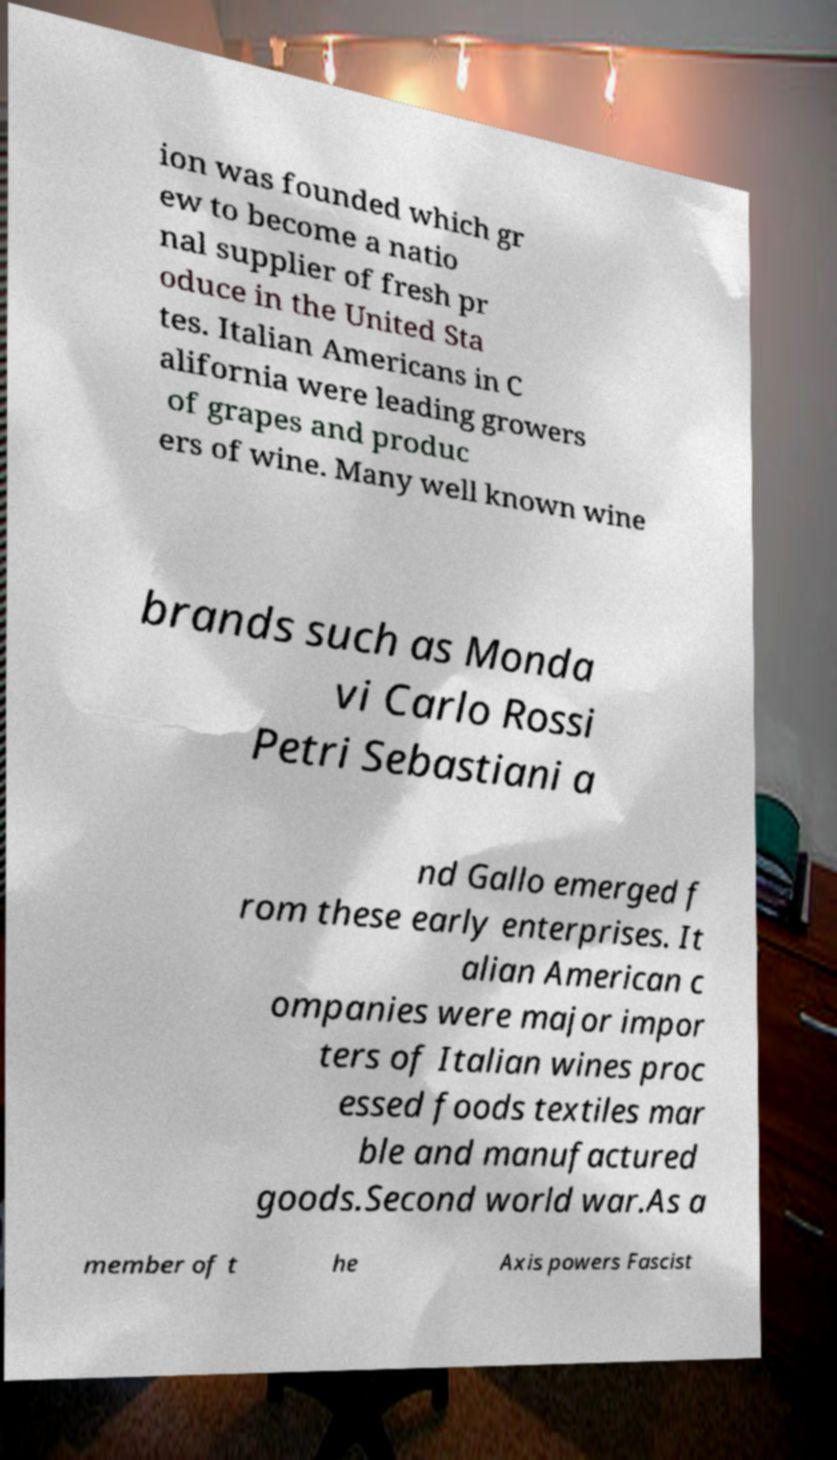Could you extract and type out the text from this image? ion was founded which gr ew to become a natio nal supplier of fresh pr oduce in the United Sta tes. Italian Americans in C alifornia were leading growers of grapes and produc ers of wine. Many well known wine brands such as Monda vi Carlo Rossi Petri Sebastiani a nd Gallo emerged f rom these early enterprises. It alian American c ompanies were major impor ters of Italian wines proc essed foods textiles mar ble and manufactured goods.Second world war.As a member of t he Axis powers Fascist 